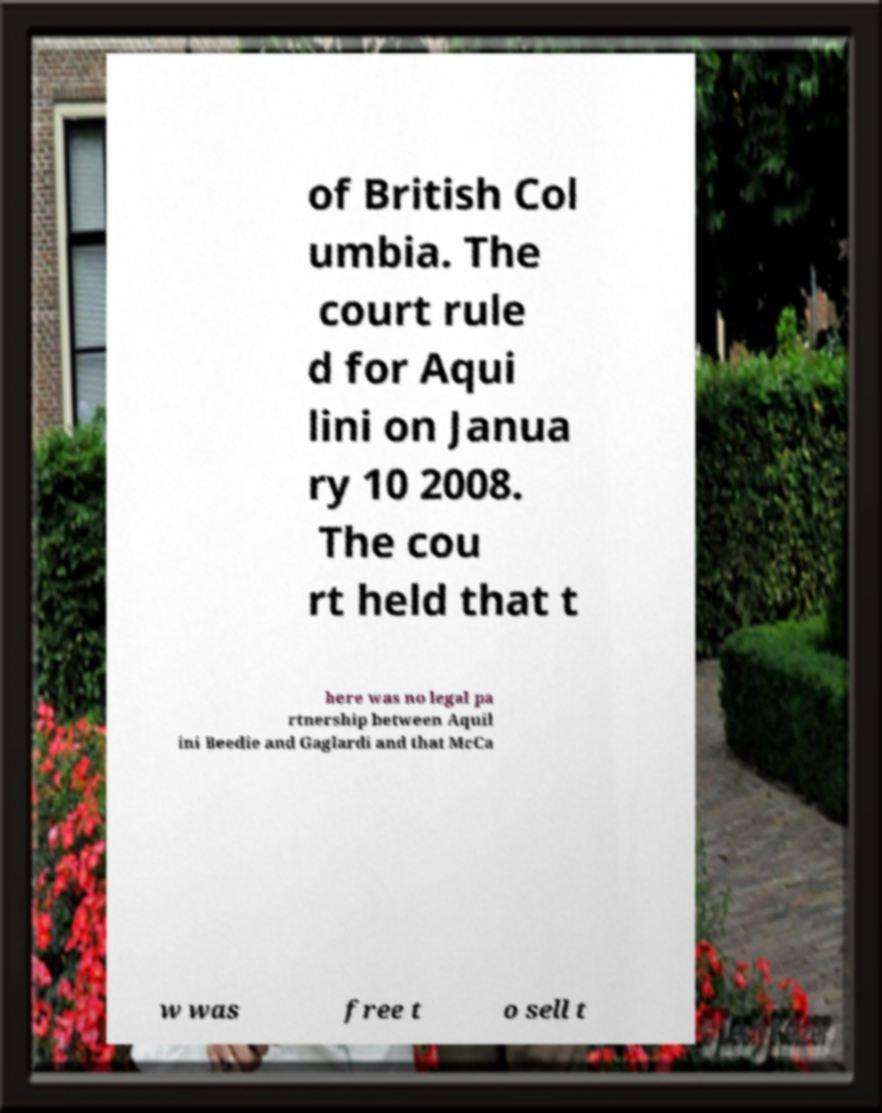Please read and relay the text visible in this image. What does it say? of British Col umbia. The court rule d for Aqui lini on Janua ry 10 2008. The cou rt held that t here was no legal pa rtnership between Aquil ini Beedie and Gaglardi and that McCa w was free t o sell t 